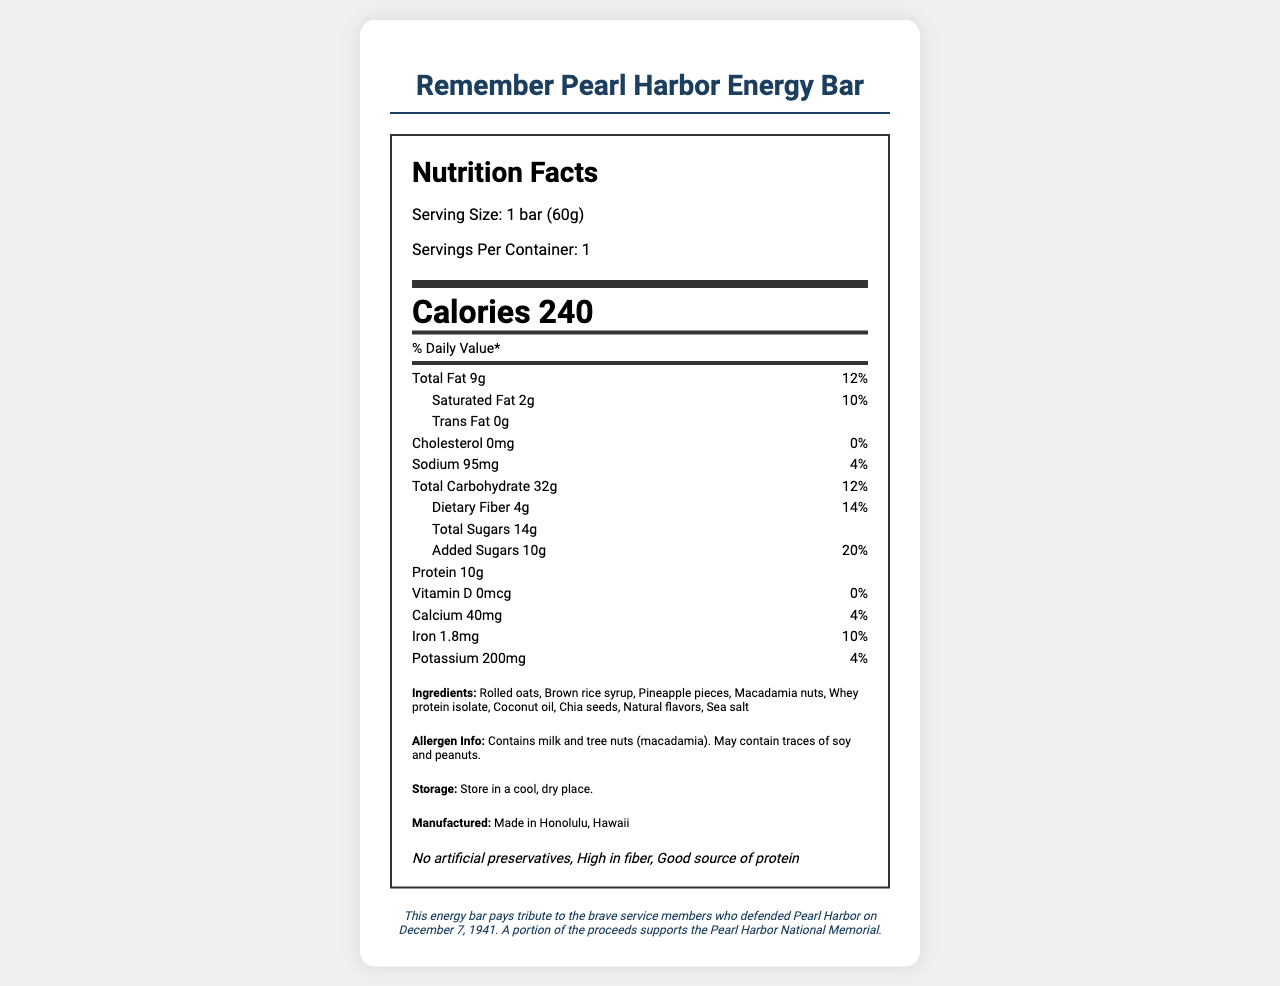what is the serving size of the energy bar? The serving size is listed at the top of the nutrition label as "Serving Size: 1 bar (60g)."
Answer: 1 bar (60g) how many calories are in one bar? The number of calories is prominently displayed under the serving size information as "Calories 240."
Answer: 240 what is the daily value percentage of total fat? The daily value percentage for total fat is listed next to the amount (9g) as "12%."
Answer: 12% does the energy bar contain any trans fat? The label indicates "Trans Fat 0g," meaning it contains no trans fat.
Answer: No what are the main protein sources in the ingredients? The ingredient list includes "Whey protein isolate," which is a primary protein source.
Answer: Whey protein isolate which of the following is an ingredient in the energy bar? A. Almonds B. Macadamia nuts C. Walnuts The ingredients list includes "Macadamia nuts" but not almonds or walnuts.
Answer: B how much sodium does the energy bar have? A. 60mg B. 95mg C. 120mg The sodium content is listed as "Sodium 95mg."
Answer: B does this energy bar contain any cholesterol? The label shows "Cholesterol 0mg," indicating there is no cholesterol.
Answer: No is the energy bar high in vitamin D? The label shows "Vitamin D 0mcg" with a daily value percentage of "0%."
Answer: No does this product contain any gluten? The label does not provide information on whether the product contains gluten.
Answer: Not enough information what is a notable historical aspect of this energy bar? The historical note at the bottom of the document mentions that the energy bar pays tribute to the brave service members who defended Pearl Harbor on December 7, 1941.
Answer: It pays tribute to the brave service members who defended Pearl Harbor on December 7, 1941. how many grams of protein does the energy bar contain? The nutrition label lists "Protein 10g."
Answer: 10g which allergen is present in the energy bar? A. Soy B. Peanuts C. Milk The allergen information states "Contains milk and tree nuts (macadamia). May contain traces of soy and peanuts."
Answer: C are there any added sugars in the energy bar? The label indicates "Added Sugars 10g."
Answer: Yes in which location is this energy bar manufactured? The manufacturing location is listed as "Made in Honolulu, Hawaii."
Answer: Honolulu, Hawaii what are the special features of this energy bar? The special features are listed under "No artificial preservatives, High in fiber, Good source of protein."
Answer: No artificial preservatives, High in fiber, Good source of protein summarize the main information on the "Remember Pearl Harbor Energy Bar" nutrition label. The answer encapsulates the essential nutritional values, ingredients, allergen info, manufacturing location, special features, and the historical note about the bar.
Answer: The Remember Pearl Harbor Energy Bar contains 240 calories per bar (60g). It has 9g of total fat (12% DV), 2g of saturated fat (10% DV), 0g of trans fat, 0mg of cholesterol, 95mg of sodium (4% DV), 32g of carbohydrates (12% DV), 4g of dietary fiber (14% DV), 14g of total sugars with 10g added sugars (20% DV), and 10g of protein. The ingredients include rolled oats, brown rice syrup, pineapple pieces, macadamia nuts, whey protein isolate, coconut oil, chia seeds, natural flavors, and sea salt. It contains milk and macadamia nuts and may have traces of soy and peanuts. Made in Honolulu, Hawaii, it has special features like no artificial preservatives, high fiber, and good protein sources. It pays tribute to Pearl Harbor's defenders, and a portion of proceeds supports the Pearl Harbor Memorial. 